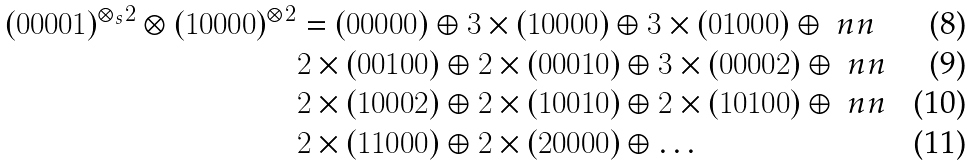Convert formula to latex. <formula><loc_0><loc_0><loc_500><loc_500>( 0 0 0 0 1 ) ^ { { \otimes } _ { s } 2 } \otimes ( 1 0 0 0 0 ) ^ { \otimes 2 } & = ( 0 0 0 0 0 ) \oplus 3 \times ( 1 0 0 0 0 ) \oplus 3 \times ( 0 1 0 0 0 ) \oplus \ n n \\ & 2 \times ( 0 0 1 0 0 ) \oplus 2 \times ( 0 0 0 1 0 ) \oplus 3 \times ( 0 0 0 0 2 ) \oplus \ n n \\ & 2 \times ( 1 0 0 0 2 ) \oplus 2 \times ( 1 0 0 1 0 ) \oplus 2 \times ( 1 0 1 0 0 ) \oplus \ n n \\ & 2 \times ( 1 1 0 0 0 ) \oplus 2 \times ( 2 0 0 0 0 ) \oplus \dots</formula> 